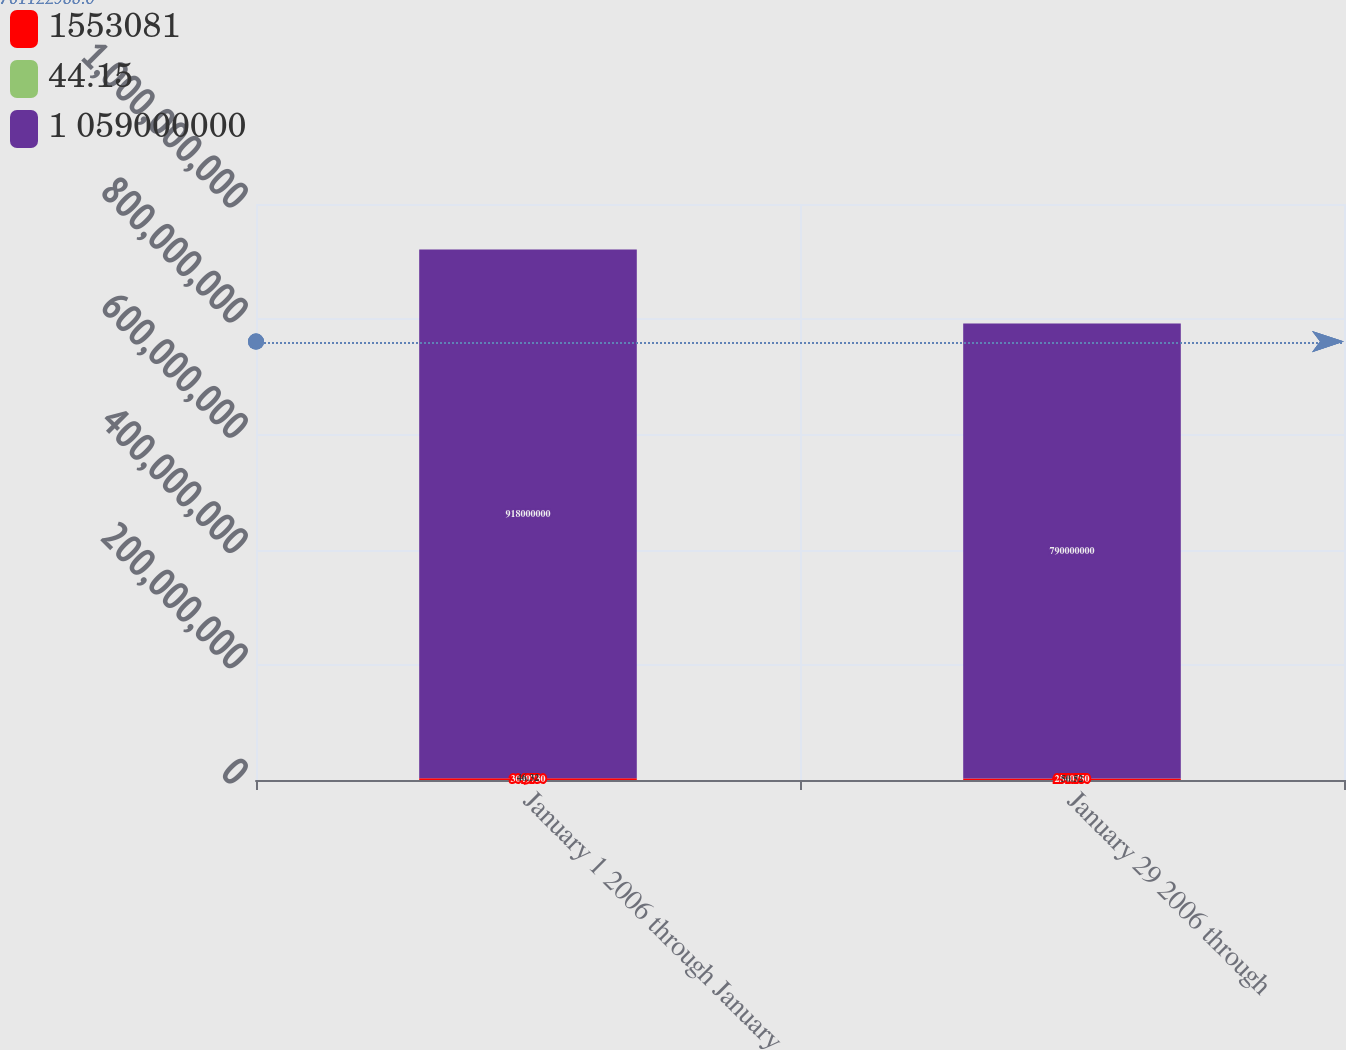<chart> <loc_0><loc_0><loc_500><loc_500><stacked_bar_chart><ecel><fcel>January 1 2006 through January<fcel>January 29 2006 through<nl><fcel>1553081<fcel>3.04973e+06<fcel>2.54075e+06<nl><fcel>44.15<fcel>46.32<fcel>50.52<nl><fcel>1 059000000<fcel>9.18e+08<fcel>7.9e+08<nl></chart> 